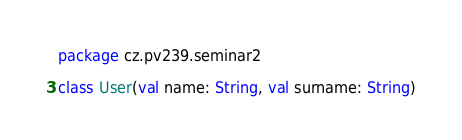<code> <loc_0><loc_0><loc_500><loc_500><_Kotlin_>package cz.pv239.seminar2

class User(val name: String, val surname: String)
</code> 